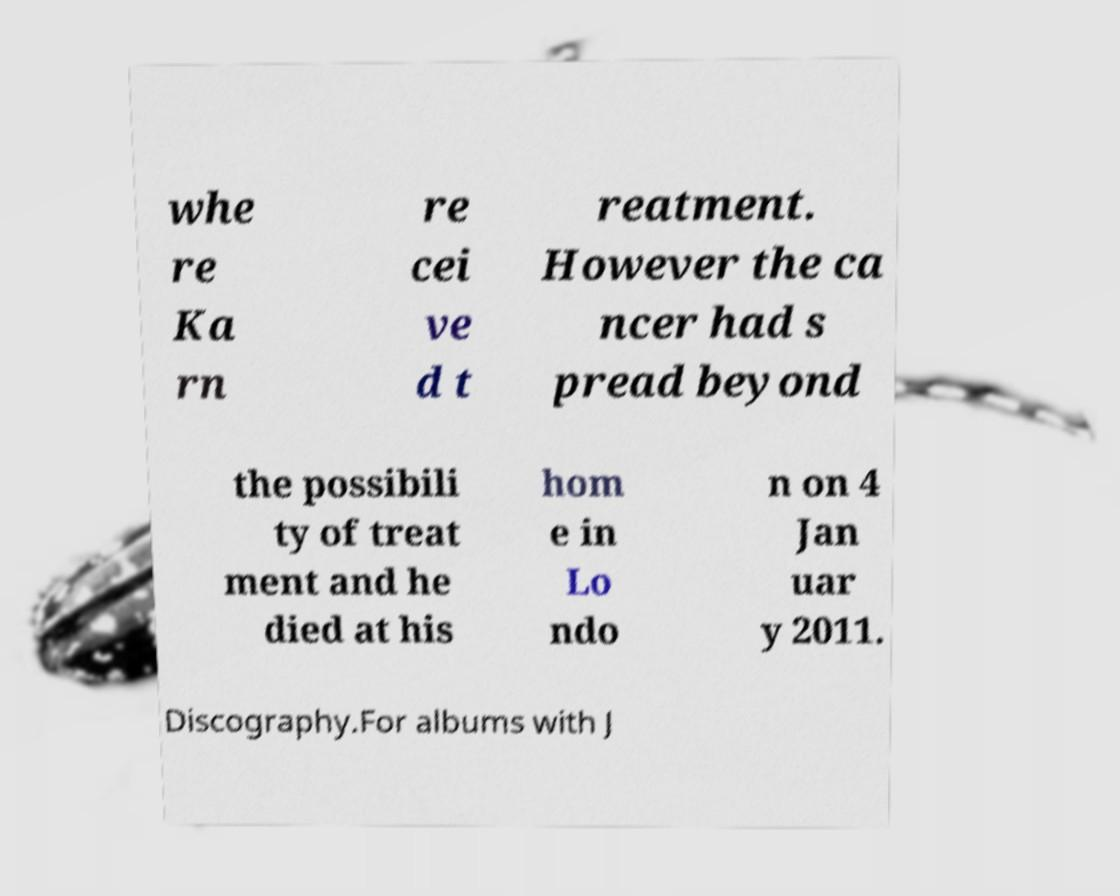For documentation purposes, I need the text within this image transcribed. Could you provide that? whe re Ka rn re cei ve d t reatment. However the ca ncer had s pread beyond the possibili ty of treat ment and he died at his hom e in Lo ndo n on 4 Jan uar y 2011. Discography.For albums with J 